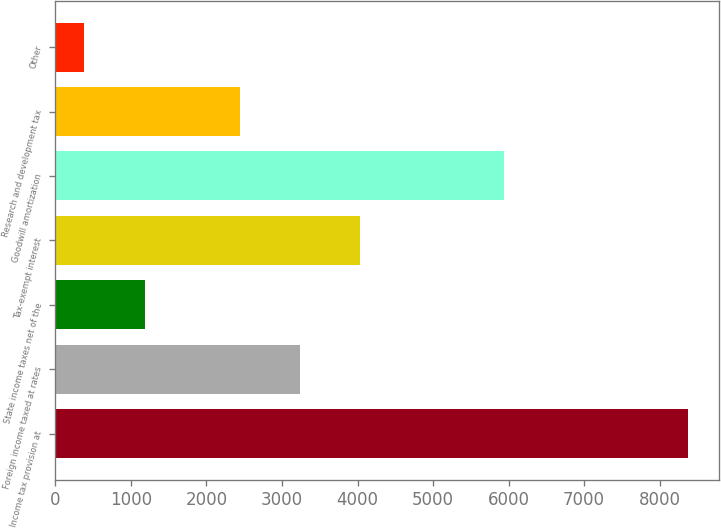<chart> <loc_0><loc_0><loc_500><loc_500><bar_chart><fcel>Income tax provision at<fcel>Foreign income taxed at rates<fcel>State income taxes net of the<fcel>Tax-exempt interest<fcel>Goodwill amortization<fcel>Research and development tax<fcel>Other<nl><fcel>8372<fcel>3236.9<fcel>1181.9<fcel>4035.8<fcel>5945<fcel>2438<fcel>383<nl></chart> 